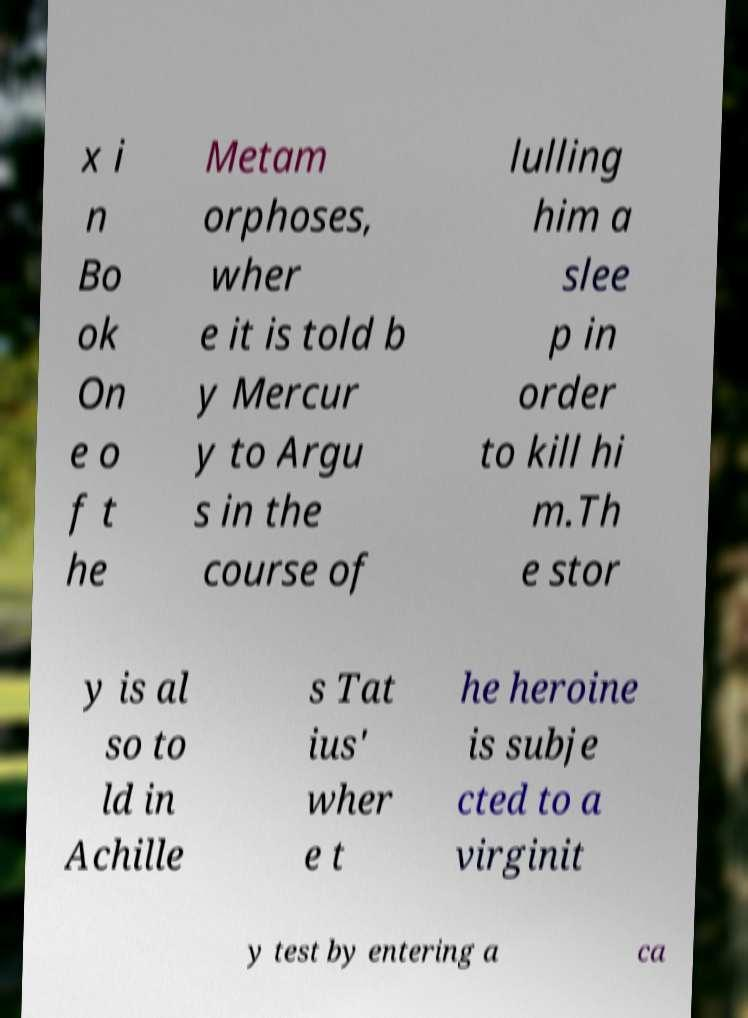Please identify and transcribe the text found in this image. x i n Bo ok On e o f t he Metam orphoses, wher e it is told b y Mercur y to Argu s in the course of lulling him a slee p in order to kill hi m.Th e stor y is al so to ld in Achille s Tat ius' wher e t he heroine is subje cted to a virginit y test by entering a ca 